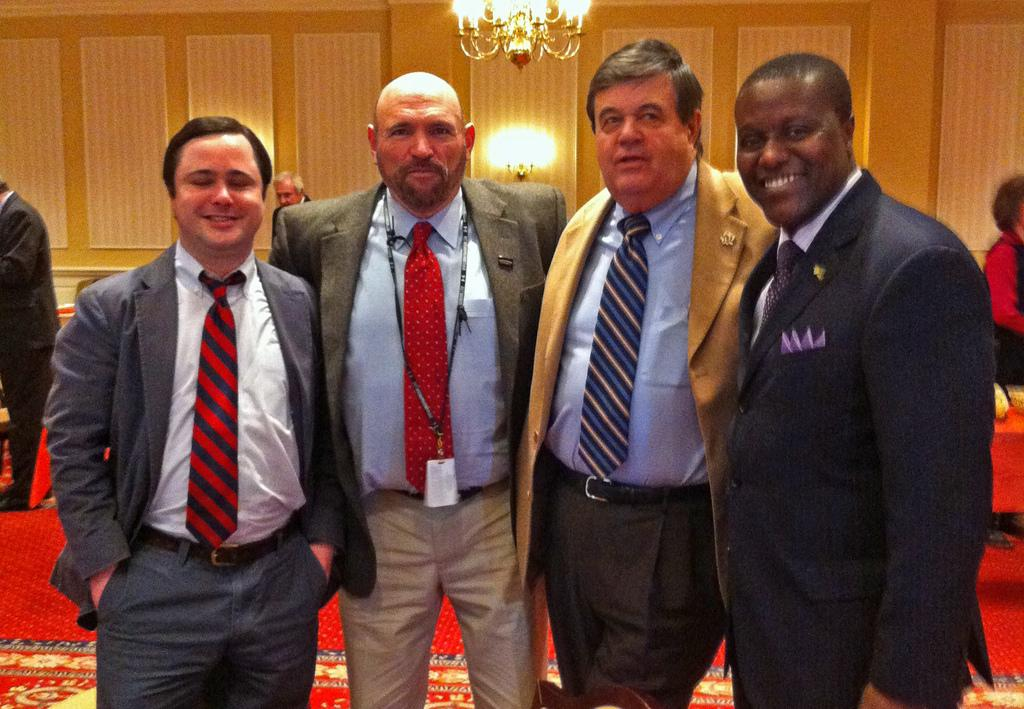What can be observed about the people in the image? There are people standing in the image. Can you describe the presence of people in the background of the image? There are people visible in the background of the image. What else is present in the image besides the people? There are lights present in the image. What type of drop can be seen falling from the lights in the image? There is no drop falling from the lights in the image. Can you describe the coach that is present in the image? There is no coach present in the image. 